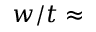Convert formula to latex. <formula><loc_0><loc_0><loc_500><loc_500>w / t \approx</formula> 